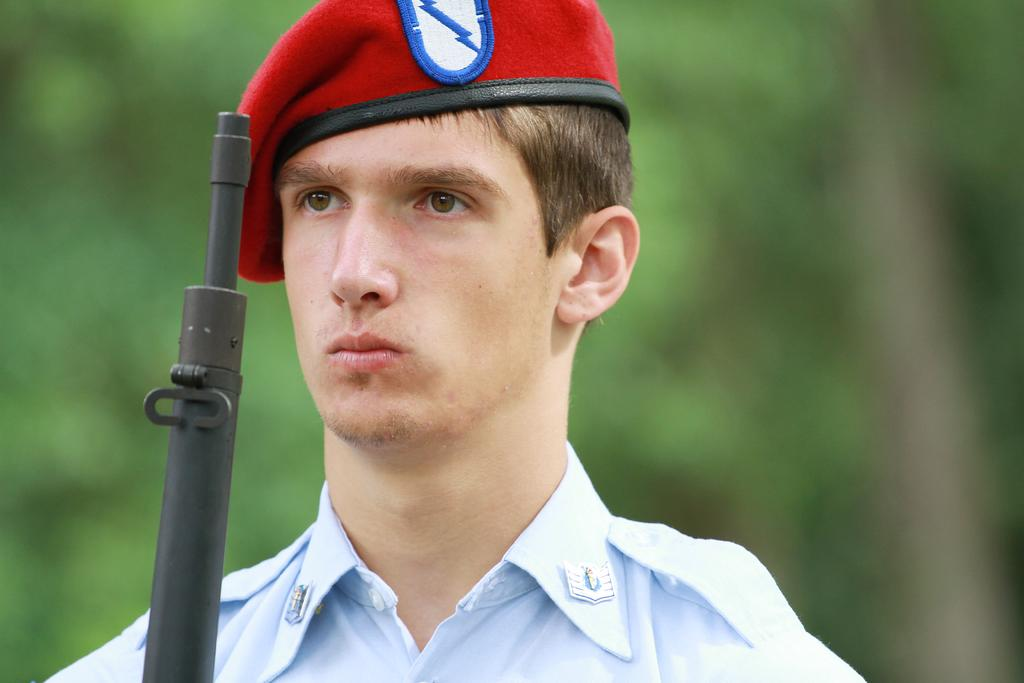What is the main subject of the image? There is a person in the image. What object can be seen with the person? There is a gun in the image. Can you describe the background of the image? The background of the image is blurred. What type of shoes is the squirrel wearing in the image? There is no squirrel present in the image, and therefore no shoes to describe. 